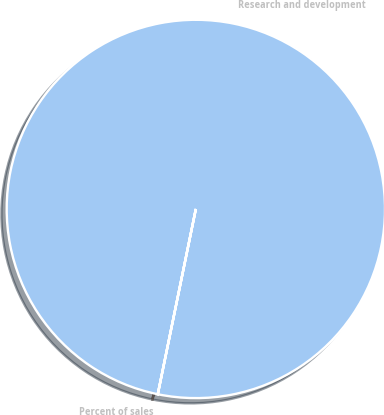Convert chart. <chart><loc_0><loc_0><loc_500><loc_500><pie_chart><fcel>Research and development<fcel>Percent of sales<nl><fcel>99.99%<fcel>0.01%<nl></chart> 